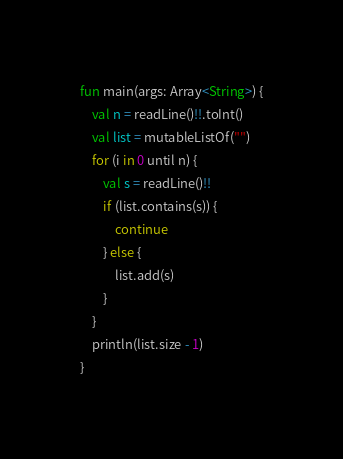Convert code to text. <code><loc_0><loc_0><loc_500><loc_500><_Kotlin_>fun main(args: Array<String>) {
    val n = readLine()!!.toInt()
    val list = mutableListOf("")
    for (i in 0 until n) {
        val s = readLine()!!
        if (list.contains(s)) {
            continue
        } else {
            list.add(s)
        }
    }
    println(list.size - 1)
}
</code> 